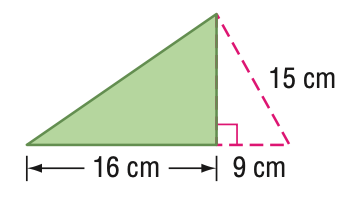Answer the mathemtical geometry problem and directly provide the correct option letter.
Question: Find the perimeter of the triangle. Round to the nearest tenth if necessary.
Choices: A: 24 B: 48 C: 56 D: 96 B 